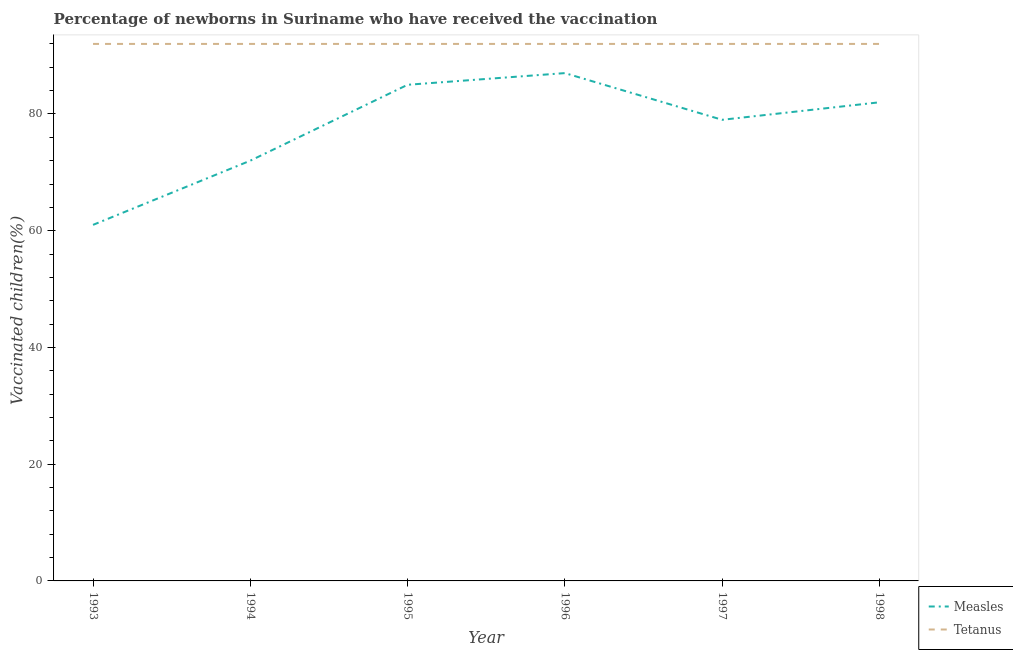How many different coloured lines are there?
Offer a terse response. 2. Does the line corresponding to percentage of newborns who received vaccination for measles intersect with the line corresponding to percentage of newborns who received vaccination for tetanus?
Your answer should be compact. No. What is the percentage of newborns who received vaccination for measles in 1994?
Your response must be concise. 72. Across all years, what is the maximum percentage of newborns who received vaccination for measles?
Provide a short and direct response. 87. Across all years, what is the minimum percentage of newborns who received vaccination for measles?
Offer a very short reply. 61. What is the total percentage of newborns who received vaccination for measles in the graph?
Ensure brevity in your answer.  466. What is the difference between the percentage of newborns who received vaccination for measles in 1995 and that in 1997?
Make the answer very short. 6. What is the difference between the percentage of newborns who received vaccination for tetanus in 1994 and the percentage of newborns who received vaccination for measles in 1993?
Offer a terse response. 31. What is the average percentage of newborns who received vaccination for measles per year?
Offer a terse response. 77.67. In the year 1997, what is the difference between the percentage of newborns who received vaccination for measles and percentage of newborns who received vaccination for tetanus?
Ensure brevity in your answer.  -13. Is the percentage of newborns who received vaccination for measles in 1993 less than that in 1998?
Provide a short and direct response. Yes. Is the difference between the percentage of newborns who received vaccination for measles in 1996 and 1997 greater than the difference between the percentage of newborns who received vaccination for tetanus in 1996 and 1997?
Give a very brief answer. Yes. What is the difference between the highest and the second highest percentage of newborns who received vaccination for measles?
Ensure brevity in your answer.  2. In how many years, is the percentage of newborns who received vaccination for tetanus greater than the average percentage of newborns who received vaccination for tetanus taken over all years?
Your response must be concise. 0. Does the percentage of newborns who received vaccination for measles monotonically increase over the years?
Your answer should be very brief. No. Is the percentage of newborns who received vaccination for measles strictly greater than the percentage of newborns who received vaccination for tetanus over the years?
Make the answer very short. No. Is the percentage of newborns who received vaccination for measles strictly less than the percentage of newborns who received vaccination for tetanus over the years?
Ensure brevity in your answer.  Yes. How many lines are there?
Provide a short and direct response. 2. How many years are there in the graph?
Ensure brevity in your answer.  6. Are the values on the major ticks of Y-axis written in scientific E-notation?
Ensure brevity in your answer.  No. Does the graph contain any zero values?
Offer a very short reply. No. How are the legend labels stacked?
Give a very brief answer. Vertical. What is the title of the graph?
Give a very brief answer. Percentage of newborns in Suriname who have received the vaccination. Does "From World Bank" appear as one of the legend labels in the graph?
Give a very brief answer. No. What is the label or title of the X-axis?
Provide a succinct answer. Year. What is the label or title of the Y-axis?
Ensure brevity in your answer.  Vaccinated children(%)
. What is the Vaccinated children(%)
 in Tetanus in 1993?
Your answer should be very brief. 92. What is the Vaccinated children(%)
 of Measles in 1994?
Provide a succinct answer. 72. What is the Vaccinated children(%)
 in Tetanus in 1994?
Your response must be concise. 92. What is the Vaccinated children(%)
 in Measles in 1995?
Keep it short and to the point. 85. What is the Vaccinated children(%)
 in Tetanus in 1995?
Your answer should be compact. 92. What is the Vaccinated children(%)
 in Measles in 1996?
Keep it short and to the point. 87. What is the Vaccinated children(%)
 in Tetanus in 1996?
Your response must be concise. 92. What is the Vaccinated children(%)
 of Measles in 1997?
Offer a very short reply. 79. What is the Vaccinated children(%)
 in Tetanus in 1997?
Make the answer very short. 92. What is the Vaccinated children(%)
 in Tetanus in 1998?
Your answer should be compact. 92. Across all years, what is the maximum Vaccinated children(%)
 in Measles?
Provide a succinct answer. 87. Across all years, what is the maximum Vaccinated children(%)
 in Tetanus?
Your answer should be very brief. 92. Across all years, what is the minimum Vaccinated children(%)
 in Measles?
Keep it short and to the point. 61. Across all years, what is the minimum Vaccinated children(%)
 of Tetanus?
Keep it short and to the point. 92. What is the total Vaccinated children(%)
 of Measles in the graph?
Ensure brevity in your answer.  466. What is the total Vaccinated children(%)
 in Tetanus in the graph?
Your answer should be very brief. 552. What is the difference between the Vaccinated children(%)
 of Measles in 1993 and that in 1994?
Your answer should be very brief. -11. What is the difference between the Vaccinated children(%)
 of Tetanus in 1993 and that in 1994?
Your response must be concise. 0. What is the difference between the Vaccinated children(%)
 of Tetanus in 1993 and that in 1995?
Your response must be concise. 0. What is the difference between the Vaccinated children(%)
 in Measles in 1993 and that in 1996?
Make the answer very short. -26. What is the difference between the Vaccinated children(%)
 of Measles in 1993 and that in 1997?
Offer a very short reply. -18. What is the difference between the Vaccinated children(%)
 of Tetanus in 1993 and that in 1997?
Your answer should be compact. 0. What is the difference between the Vaccinated children(%)
 of Measles in 1993 and that in 1998?
Provide a succinct answer. -21. What is the difference between the Vaccinated children(%)
 in Measles in 1994 and that in 1995?
Your answer should be compact. -13. What is the difference between the Vaccinated children(%)
 in Measles in 1994 and that in 1998?
Your response must be concise. -10. What is the difference between the Vaccinated children(%)
 of Tetanus in 1994 and that in 1998?
Make the answer very short. 0. What is the difference between the Vaccinated children(%)
 of Tetanus in 1995 and that in 1996?
Your response must be concise. 0. What is the difference between the Vaccinated children(%)
 in Tetanus in 1995 and that in 1997?
Ensure brevity in your answer.  0. What is the difference between the Vaccinated children(%)
 of Measles in 1995 and that in 1998?
Provide a short and direct response. 3. What is the difference between the Vaccinated children(%)
 in Tetanus in 1995 and that in 1998?
Provide a succinct answer. 0. What is the difference between the Vaccinated children(%)
 in Measles in 1996 and that in 1998?
Ensure brevity in your answer.  5. What is the difference between the Vaccinated children(%)
 of Tetanus in 1997 and that in 1998?
Provide a short and direct response. 0. What is the difference between the Vaccinated children(%)
 in Measles in 1993 and the Vaccinated children(%)
 in Tetanus in 1994?
Give a very brief answer. -31. What is the difference between the Vaccinated children(%)
 of Measles in 1993 and the Vaccinated children(%)
 of Tetanus in 1995?
Provide a short and direct response. -31. What is the difference between the Vaccinated children(%)
 in Measles in 1993 and the Vaccinated children(%)
 in Tetanus in 1996?
Your answer should be compact. -31. What is the difference between the Vaccinated children(%)
 of Measles in 1993 and the Vaccinated children(%)
 of Tetanus in 1997?
Offer a very short reply. -31. What is the difference between the Vaccinated children(%)
 in Measles in 1993 and the Vaccinated children(%)
 in Tetanus in 1998?
Ensure brevity in your answer.  -31. What is the difference between the Vaccinated children(%)
 in Measles in 1994 and the Vaccinated children(%)
 in Tetanus in 1995?
Offer a terse response. -20. What is the difference between the Vaccinated children(%)
 in Measles in 1994 and the Vaccinated children(%)
 in Tetanus in 1997?
Provide a succinct answer. -20. What is the difference between the Vaccinated children(%)
 of Measles in 1994 and the Vaccinated children(%)
 of Tetanus in 1998?
Offer a terse response. -20. What is the difference between the Vaccinated children(%)
 in Measles in 1995 and the Vaccinated children(%)
 in Tetanus in 1996?
Keep it short and to the point. -7. What is the difference between the Vaccinated children(%)
 in Measles in 1995 and the Vaccinated children(%)
 in Tetanus in 1997?
Give a very brief answer. -7. What is the difference between the Vaccinated children(%)
 in Measles in 1995 and the Vaccinated children(%)
 in Tetanus in 1998?
Offer a terse response. -7. What is the average Vaccinated children(%)
 in Measles per year?
Offer a terse response. 77.67. What is the average Vaccinated children(%)
 of Tetanus per year?
Make the answer very short. 92. In the year 1993, what is the difference between the Vaccinated children(%)
 in Measles and Vaccinated children(%)
 in Tetanus?
Give a very brief answer. -31. In the year 1994, what is the difference between the Vaccinated children(%)
 in Measles and Vaccinated children(%)
 in Tetanus?
Offer a terse response. -20. In the year 1997, what is the difference between the Vaccinated children(%)
 of Measles and Vaccinated children(%)
 of Tetanus?
Make the answer very short. -13. What is the ratio of the Vaccinated children(%)
 of Measles in 1993 to that in 1994?
Make the answer very short. 0.85. What is the ratio of the Vaccinated children(%)
 of Measles in 1993 to that in 1995?
Provide a short and direct response. 0.72. What is the ratio of the Vaccinated children(%)
 of Measles in 1993 to that in 1996?
Give a very brief answer. 0.7. What is the ratio of the Vaccinated children(%)
 in Measles in 1993 to that in 1997?
Give a very brief answer. 0.77. What is the ratio of the Vaccinated children(%)
 of Measles in 1993 to that in 1998?
Make the answer very short. 0.74. What is the ratio of the Vaccinated children(%)
 of Measles in 1994 to that in 1995?
Provide a succinct answer. 0.85. What is the ratio of the Vaccinated children(%)
 in Measles in 1994 to that in 1996?
Make the answer very short. 0.83. What is the ratio of the Vaccinated children(%)
 in Tetanus in 1994 to that in 1996?
Your response must be concise. 1. What is the ratio of the Vaccinated children(%)
 of Measles in 1994 to that in 1997?
Ensure brevity in your answer.  0.91. What is the ratio of the Vaccinated children(%)
 in Measles in 1994 to that in 1998?
Your answer should be very brief. 0.88. What is the ratio of the Vaccinated children(%)
 of Tetanus in 1994 to that in 1998?
Offer a very short reply. 1. What is the ratio of the Vaccinated children(%)
 of Measles in 1995 to that in 1996?
Provide a succinct answer. 0.98. What is the ratio of the Vaccinated children(%)
 in Tetanus in 1995 to that in 1996?
Ensure brevity in your answer.  1. What is the ratio of the Vaccinated children(%)
 in Measles in 1995 to that in 1997?
Your answer should be very brief. 1.08. What is the ratio of the Vaccinated children(%)
 of Tetanus in 1995 to that in 1997?
Give a very brief answer. 1. What is the ratio of the Vaccinated children(%)
 of Measles in 1995 to that in 1998?
Offer a terse response. 1.04. What is the ratio of the Vaccinated children(%)
 in Tetanus in 1995 to that in 1998?
Give a very brief answer. 1. What is the ratio of the Vaccinated children(%)
 in Measles in 1996 to that in 1997?
Provide a short and direct response. 1.1. What is the ratio of the Vaccinated children(%)
 of Measles in 1996 to that in 1998?
Your answer should be compact. 1.06. What is the ratio of the Vaccinated children(%)
 in Measles in 1997 to that in 1998?
Make the answer very short. 0.96. What is the ratio of the Vaccinated children(%)
 in Tetanus in 1997 to that in 1998?
Provide a succinct answer. 1. What is the difference between the highest and the second highest Vaccinated children(%)
 of Tetanus?
Give a very brief answer. 0. What is the difference between the highest and the lowest Vaccinated children(%)
 in Tetanus?
Provide a short and direct response. 0. 